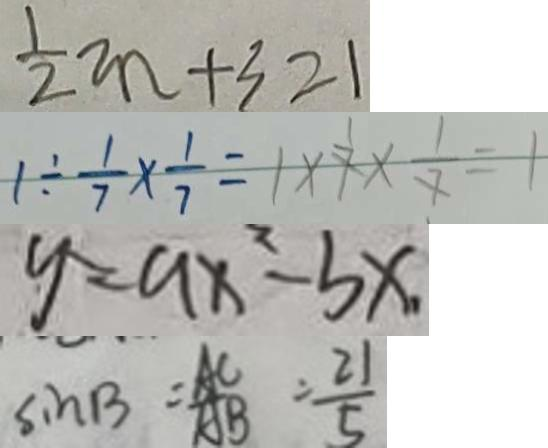Convert formula to latex. <formula><loc_0><loc_0><loc_500><loc_500>\frac { 1 } { 2 } m + 3 = 1 
 1 \div \frac { 1 } { 7 } \times \frac { 1 } { 7 } = 1 \times 7 \times \frac { 1 } { 7 } = 1 
 y = a x ^ { 2 } - b x . 
 \sin B = \frac { A C } { A B } = \frac { 2 1 } { 5 }</formula> 